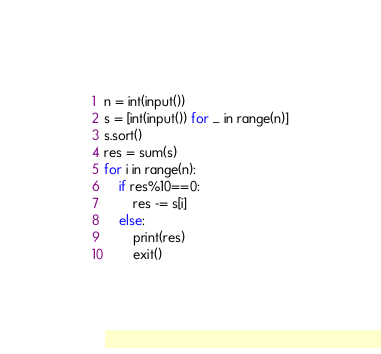<code> <loc_0><loc_0><loc_500><loc_500><_Python_>
n = int(input())
s = [int(input()) for _ in range(n)]
s.sort()
res = sum(s)
for i in range(n):
    if res%10==0:
        res -= s[i]
    else:
        print(res)
        exit()</code> 